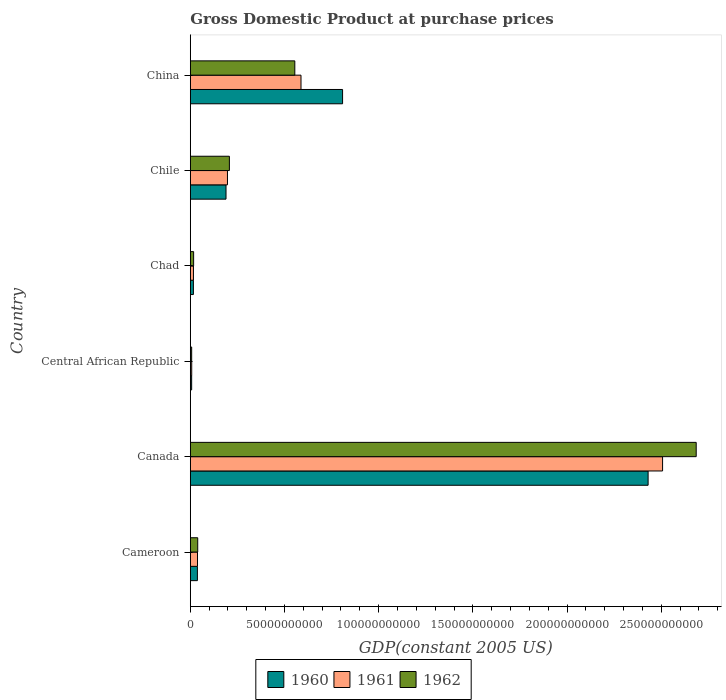How many different coloured bars are there?
Ensure brevity in your answer.  3. How many groups of bars are there?
Offer a terse response. 6. Are the number of bars per tick equal to the number of legend labels?
Keep it short and to the point. Yes. Are the number of bars on each tick of the Y-axis equal?
Offer a terse response. Yes. How many bars are there on the 6th tick from the bottom?
Offer a very short reply. 3. What is the GDP at purchase prices in 1960 in Canada?
Give a very brief answer. 2.43e+11. Across all countries, what is the maximum GDP at purchase prices in 1962?
Your response must be concise. 2.69e+11. Across all countries, what is the minimum GDP at purchase prices in 1961?
Give a very brief answer. 7.57e+08. In which country was the GDP at purchase prices in 1962 maximum?
Give a very brief answer. Canada. In which country was the GDP at purchase prices in 1961 minimum?
Provide a succinct answer. Central African Republic. What is the total GDP at purchase prices in 1962 in the graph?
Offer a very short reply. 3.51e+11. What is the difference between the GDP at purchase prices in 1960 in Cameroon and that in Canada?
Your answer should be very brief. -2.39e+11. What is the difference between the GDP at purchase prices in 1961 in Central African Republic and the GDP at purchase prices in 1960 in China?
Make the answer very short. -8.01e+1. What is the average GDP at purchase prices in 1960 per country?
Make the answer very short. 5.82e+1. What is the difference between the GDP at purchase prices in 1961 and GDP at purchase prices in 1962 in Chad?
Your answer should be compact. -8.98e+07. What is the ratio of the GDP at purchase prices in 1962 in Canada to that in Central African Republic?
Ensure brevity in your answer.  368.49. Is the GDP at purchase prices in 1962 in Cameroon less than that in Chile?
Offer a terse response. Yes. Is the difference between the GDP at purchase prices in 1961 in Canada and Central African Republic greater than the difference between the GDP at purchase prices in 1962 in Canada and Central African Republic?
Give a very brief answer. No. What is the difference between the highest and the second highest GDP at purchase prices in 1962?
Give a very brief answer. 2.13e+11. What is the difference between the highest and the lowest GDP at purchase prices in 1962?
Your answer should be very brief. 2.68e+11. In how many countries, is the GDP at purchase prices in 1961 greater than the average GDP at purchase prices in 1961 taken over all countries?
Your response must be concise. 2. Is the sum of the GDP at purchase prices in 1960 in Cameroon and Chad greater than the maximum GDP at purchase prices in 1961 across all countries?
Make the answer very short. No. What does the 2nd bar from the bottom in Chile represents?
Offer a terse response. 1961. How many countries are there in the graph?
Your response must be concise. 6. What is the difference between two consecutive major ticks on the X-axis?
Your response must be concise. 5.00e+1. Are the values on the major ticks of X-axis written in scientific E-notation?
Offer a very short reply. No. Does the graph contain any zero values?
Keep it short and to the point. No. Where does the legend appear in the graph?
Offer a terse response. Bottom center. What is the title of the graph?
Offer a very short reply. Gross Domestic Product at purchase prices. Does "1972" appear as one of the legend labels in the graph?
Your answer should be compact. No. What is the label or title of the X-axis?
Keep it short and to the point. GDP(constant 2005 US). What is the label or title of the Y-axis?
Keep it short and to the point. Country. What is the GDP(constant 2005 US) in 1960 in Cameroon?
Ensure brevity in your answer.  3.78e+09. What is the GDP(constant 2005 US) of 1961 in Cameroon?
Ensure brevity in your answer.  3.82e+09. What is the GDP(constant 2005 US) in 1962 in Cameroon?
Your response must be concise. 3.94e+09. What is the GDP(constant 2005 US) of 1960 in Canada?
Keep it short and to the point. 2.43e+11. What is the GDP(constant 2005 US) of 1961 in Canada?
Your response must be concise. 2.51e+11. What is the GDP(constant 2005 US) in 1962 in Canada?
Offer a very short reply. 2.69e+11. What is the GDP(constant 2005 US) in 1960 in Central African Republic?
Make the answer very short. 7.21e+08. What is the GDP(constant 2005 US) of 1961 in Central African Republic?
Give a very brief answer. 7.57e+08. What is the GDP(constant 2005 US) of 1962 in Central African Republic?
Your response must be concise. 7.29e+08. What is the GDP(constant 2005 US) in 1960 in Chad?
Ensure brevity in your answer.  1.65e+09. What is the GDP(constant 2005 US) in 1961 in Chad?
Your answer should be very brief. 1.68e+09. What is the GDP(constant 2005 US) of 1962 in Chad?
Keep it short and to the point. 1.77e+09. What is the GDP(constant 2005 US) in 1960 in Chile?
Ensure brevity in your answer.  1.90e+1. What is the GDP(constant 2005 US) of 1961 in Chile?
Provide a succinct answer. 1.97e+1. What is the GDP(constant 2005 US) of 1962 in Chile?
Offer a terse response. 2.08e+1. What is the GDP(constant 2005 US) of 1960 in China?
Give a very brief answer. 8.08e+1. What is the GDP(constant 2005 US) of 1961 in China?
Make the answer very short. 5.88e+1. What is the GDP(constant 2005 US) in 1962 in China?
Ensure brevity in your answer.  5.55e+1. Across all countries, what is the maximum GDP(constant 2005 US) in 1960?
Your response must be concise. 2.43e+11. Across all countries, what is the maximum GDP(constant 2005 US) of 1961?
Provide a short and direct response. 2.51e+11. Across all countries, what is the maximum GDP(constant 2005 US) of 1962?
Ensure brevity in your answer.  2.69e+11. Across all countries, what is the minimum GDP(constant 2005 US) in 1960?
Provide a short and direct response. 7.21e+08. Across all countries, what is the minimum GDP(constant 2005 US) of 1961?
Offer a very short reply. 7.57e+08. Across all countries, what is the minimum GDP(constant 2005 US) in 1962?
Offer a terse response. 7.29e+08. What is the total GDP(constant 2005 US) of 1960 in the graph?
Your answer should be very brief. 3.49e+11. What is the total GDP(constant 2005 US) of 1961 in the graph?
Provide a short and direct response. 3.35e+11. What is the total GDP(constant 2005 US) of 1962 in the graph?
Your response must be concise. 3.51e+11. What is the difference between the GDP(constant 2005 US) in 1960 in Cameroon and that in Canada?
Keep it short and to the point. -2.39e+11. What is the difference between the GDP(constant 2005 US) of 1961 in Cameroon and that in Canada?
Your answer should be compact. -2.47e+11. What is the difference between the GDP(constant 2005 US) in 1962 in Cameroon and that in Canada?
Offer a terse response. -2.65e+11. What is the difference between the GDP(constant 2005 US) in 1960 in Cameroon and that in Central African Republic?
Your answer should be compact. 3.06e+09. What is the difference between the GDP(constant 2005 US) in 1961 in Cameroon and that in Central African Republic?
Keep it short and to the point. 3.07e+09. What is the difference between the GDP(constant 2005 US) in 1962 in Cameroon and that in Central African Republic?
Your answer should be very brief. 3.21e+09. What is the difference between the GDP(constant 2005 US) in 1960 in Cameroon and that in Chad?
Make the answer very short. 2.13e+09. What is the difference between the GDP(constant 2005 US) in 1961 in Cameroon and that in Chad?
Your answer should be very brief. 2.15e+09. What is the difference between the GDP(constant 2005 US) in 1962 in Cameroon and that in Chad?
Your answer should be very brief. 2.17e+09. What is the difference between the GDP(constant 2005 US) of 1960 in Cameroon and that in Chile?
Ensure brevity in your answer.  -1.52e+1. What is the difference between the GDP(constant 2005 US) in 1961 in Cameroon and that in Chile?
Your answer should be compact. -1.59e+1. What is the difference between the GDP(constant 2005 US) of 1962 in Cameroon and that in Chile?
Offer a very short reply. -1.68e+1. What is the difference between the GDP(constant 2005 US) of 1960 in Cameroon and that in China?
Your answer should be compact. -7.71e+1. What is the difference between the GDP(constant 2005 US) of 1961 in Cameroon and that in China?
Offer a terse response. -5.49e+1. What is the difference between the GDP(constant 2005 US) in 1962 in Cameroon and that in China?
Provide a succinct answer. -5.15e+1. What is the difference between the GDP(constant 2005 US) of 1960 in Canada and that in Central African Republic?
Your answer should be very brief. 2.42e+11. What is the difference between the GDP(constant 2005 US) in 1961 in Canada and that in Central African Republic?
Give a very brief answer. 2.50e+11. What is the difference between the GDP(constant 2005 US) in 1962 in Canada and that in Central African Republic?
Your answer should be very brief. 2.68e+11. What is the difference between the GDP(constant 2005 US) of 1960 in Canada and that in Chad?
Offer a very short reply. 2.41e+11. What is the difference between the GDP(constant 2005 US) of 1961 in Canada and that in Chad?
Your answer should be very brief. 2.49e+11. What is the difference between the GDP(constant 2005 US) in 1962 in Canada and that in Chad?
Provide a succinct answer. 2.67e+11. What is the difference between the GDP(constant 2005 US) in 1960 in Canada and that in Chile?
Keep it short and to the point. 2.24e+11. What is the difference between the GDP(constant 2005 US) of 1961 in Canada and that in Chile?
Make the answer very short. 2.31e+11. What is the difference between the GDP(constant 2005 US) in 1962 in Canada and that in Chile?
Provide a short and direct response. 2.48e+11. What is the difference between the GDP(constant 2005 US) in 1960 in Canada and that in China?
Offer a terse response. 1.62e+11. What is the difference between the GDP(constant 2005 US) in 1961 in Canada and that in China?
Keep it short and to the point. 1.92e+11. What is the difference between the GDP(constant 2005 US) in 1962 in Canada and that in China?
Provide a succinct answer. 2.13e+11. What is the difference between the GDP(constant 2005 US) in 1960 in Central African Republic and that in Chad?
Offer a very short reply. -9.31e+08. What is the difference between the GDP(constant 2005 US) of 1961 in Central African Republic and that in Chad?
Give a very brief answer. -9.18e+08. What is the difference between the GDP(constant 2005 US) in 1962 in Central African Republic and that in Chad?
Make the answer very short. -1.04e+09. What is the difference between the GDP(constant 2005 US) of 1960 in Central African Republic and that in Chile?
Provide a succinct answer. -1.82e+1. What is the difference between the GDP(constant 2005 US) in 1961 in Central African Republic and that in Chile?
Make the answer very short. -1.90e+1. What is the difference between the GDP(constant 2005 US) in 1962 in Central African Republic and that in Chile?
Provide a succinct answer. -2.00e+1. What is the difference between the GDP(constant 2005 US) in 1960 in Central African Republic and that in China?
Offer a terse response. -8.01e+1. What is the difference between the GDP(constant 2005 US) of 1961 in Central African Republic and that in China?
Your answer should be very brief. -5.80e+1. What is the difference between the GDP(constant 2005 US) in 1962 in Central African Republic and that in China?
Your answer should be very brief. -5.48e+1. What is the difference between the GDP(constant 2005 US) of 1960 in Chad and that in Chile?
Provide a short and direct response. -1.73e+1. What is the difference between the GDP(constant 2005 US) in 1961 in Chad and that in Chile?
Ensure brevity in your answer.  -1.81e+1. What is the difference between the GDP(constant 2005 US) in 1962 in Chad and that in Chile?
Give a very brief answer. -1.90e+1. What is the difference between the GDP(constant 2005 US) in 1960 in Chad and that in China?
Offer a very short reply. -7.92e+1. What is the difference between the GDP(constant 2005 US) of 1961 in Chad and that in China?
Your answer should be compact. -5.71e+1. What is the difference between the GDP(constant 2005 US) in 1962 in Chad and that in China?
Provide a short and direct response. -5.37e+1. What is the difference between the GDP(constant 2005 US) in 1960 in Chile and that in China?
Make the answer very short. -6.19e+1. What is the difference between the GDP(constant 2005 US) in 1961 in Chile and that in China?
Ensure brevity in your answer.  -3.90e+1. What is the difference between the GDP(constant 2005 US) in 1962 in Chile and that in China?
Your answer should be very brief. -3.47e+1. What is the difference between the GDP(constant 2005 US) in 1960 in Cameroon and the GDP(constant 2005 US) in 1961 in Canada?
Make the answer very short. -2.47e+11. What is the difference between the GDP(constant 2005 US) in 1960 in Cameroon and the GDP(constant 2005 US) in 1962 in Canada?
Provide a short and direct response. -2.65e+11. What is the difference between the GDP(constant 2005 US) of 1961 in Cameroon and the GDP(constant 2005 US) of 1962 in Canada?
Provide a short and direct response. -2.65e+11. What is the difference between the GDP(constant 2005 US) of 1960 in Cameroon and the GDP(constant 2005 US) of 1961 in Central African Republic?
Provide a succinct answer. 3.02e+09. What is the difference between the GDP(constant 2005 US) of 1960 in Cameroon and the GDP(constant 2005 US) of 1962 in Central African Republic?
Give a very brief answer. 3.05e+09. What is the difference between the GDP(constant 2005 US) in 1961 in Cameroon and the GDP(constant 2005 US) in 1962 in Central African Republic?
Keep it short and to the point. 3.09e+09. What is the difference between the GDP(constant 2005 US) in 1960 in Cameroon and the GDP(constant 2005 US) in 1961 in Chad?
Offer a very short reply. 2.10e+09. What is the difference between the GDP(constant 2005 US) of 1960 in Cameroon and the GDP(constant 2005 US) of 1962 in Chad?
Give a very brief answer. 2.01e+09. What is the difference between the GDP(constant 2005 US) in 1961 in Cameroon and the GDP(constant 2005 US) in 1962 in Chad?
Your response must be concise. 2.06e+09. What is the difference between the GDP(constant 2005 US) of 1960 in Cameroon and the GDP(constant 2005 US) of 1961 in Chile?
Keep it short and to the point. -1.60e+1. What is the difference between the GDP(constant 2005 US) in 1960 in Cameroon and the GDP(constant 2005 US) in 1962 in Chile?
Provide a short and direct response. -1.70e+1. What is the difference between the GDP(constant 2005 US) in 1961 in Cameroon and the GDP(constant 2005 US) in 1962 in Chile?
Offer a terse response. -1.69e+1. What is the difference between the GDP(constant 2005 US) of 1960 in Cameroon and the GDP(constant 2005 US) of 1961 in China?
Your answer should be compact. -5.50e+1. What is the difference between the GDP(constant 2005 US) of 1960 in Cameroon and the GDP(constant 2005 US) of 1962 in China?
Provide a short and direct response. -5.17e+1. What is the difference between the GDP(constant 2005 US) of 1961 in Cameroon and the GDP(constant 2005 US) of 1962 in China?
Ensure brevity in your answer.  -5.17e+1. What is the difference between the GDP(constant 2005 US) in 1960 in Canada and the GDP(constant 2005 US) in 1961 in Central African Republic?
Your answer should be compact. 2.42e+11. What is the difference between the GDP(constant 2005 US) of 1960 in Canada and the GDP(constant 2005 US) of 1962 in Central African Republic?
Your answer should be compact. 2.42e+11. What is the difference between the GDP(constant 2005 US) of 1961 in Canada and the GDP(constant 2005 US) of 1962 in Central African Republic?
Provide a short and direct response. 2.50e+11. What is the difference between the GDP(constant 2005 US) in 1960 in Canada and the GDP(constant 2005 US) in 1961 in Chad?
Offer a terse response. 2.41e+11. What is the difference between the GDP(constant 2005 US) in 1960 in Canada and the GDP(constant 2005 US) in 1962 in Chad?
Provide a succinct answer. 2.41e+11. What is the difference between the GDP(constant 2005 US) of 1961 in Canada and the GDP(constant 2005 US) of 1962 in Chad?
Provide a succinct answer. 2.49e+11. What is the difference between the GDP(constant 2005 US) of 1960 in Canada and the GDP(constant 2005 US) of 1961 in Chile?
Provide a succinct answer. 2.23e+11. What is the difference between the GDP(constant 2005 US) of 1960 in Canada and the GDP(constant 2005 US) of 1962 in Chile?
Ensure brevity in your answer.  2.22e+11. What is the difference between the GDP(constant 2005 US) of 1961 in Canada and the GDP(constant 2005 US) of 1962 in Chile?
Keep it short and to the point. 2.30e+11. What is the difference between the GDP(constant 2005 US) in 1960 in Canada and the GDP(constant 2005 US) in 1961 in China?
Your answer should be compact. 1.84e+11. What is the difference between the GDP(constant 2005 US) in 1960 in Canada and the GDP(constant 2005 US) in 1962 in China?
Give a very brief answer. 1.88e+11. What is the difference between the GDP(constant 2005 US) in 1961 in Canada and the GDP(constant 2005 US) in 1962 in China?
Give a very brief answer. 1.95e+11. What is the difference between the GDP(constant 2005 US) of 1960 in Central African Republic and the GDP(constant 2005 US) of 1961 in Chad?
Ensure brevity in your answer.  -9.54e+08. What is the difference between the GDP(constant 2005 US) of 1960 in Central African Republic and the GDP(constant 2005 US) of 1962 in Chad?
Your answer should be compact. -1.04e+09. What is the difference between the GDP(constant 2005 US) in 1961 in Central African Republic and the GDP(constant 2005 US) in 1962 in Chad?
Ensure brevity in your answer.  -1.01e+09. What is the difference between the GDP(constant 2005 US) in 1960 in Central African Republic and the GDP(constant 2005 US) in 1961 in Chile?
Your response must be concise. -1.90e+1. What is the difference between the GDP(constant 2005 US) in 1960 in Central African Republic and the GDP(constant 2005 US) in 1962 in Chile?
Make the answer very short. -2.00e+1. What is the difference between the GDP(constant 2005 US) of 1961 in Central African Republic and the GDP(constant 2005 US) of 1962 in Chile?
Your answer should be very brief. -2.00e+1. What is the difference between the GDP(constant 2005 US) in 1960 in Central African Republic and the GDP(constant 2005 US) in 1961 in China?
Ensure brevity in your answer.  -5.81e+1. What is the difference between the GDP(constant 2005 US) in 1960 in Central African Republic and the GDP(constant 2005 US) in 1962 in China?
Provide a succinct answer. -5.48e+1. What is the difference between the GDP(constant 2005 US) of 1961 in Central African Republic and the GDP(constant 2005 US) of 1962 in China?
Provide a short and direct response. -5.47e+1. What is the difference between the GDP(constant 2005 US) of 1960 in Chad and the GDP(constant 2005 US) of 1961 in Chile?
Your answer should be compact. -1.81e+1. What is the difference between the GDP(constant 2005 US) of 1960 in Chad and the GDP(constant 2005 US) of 1962 in Chile?
Provide a short and direct response. -1.91e+1. What is the difference between the GDP(constant 2005 US) of 1961 in Chad and the GDP(constant 2005 US) of 1962 in Chile?
Your answer should be very brief. -1.91e+1. What is the difference between the GDP(constant 2005 US) of 1960 in Chad and the GDP(constant 2005 US) of 1961 in China?
Ensure brevity in your answer.  -5.71e+1. What is the difference between the GDP(constant 2005 US) of 1960 in Chad and the GDP(constant 2005 US) of 1962 in China?
Keep it short and to the point. -5.38e+1. What is the difference between the GDP(constant 2005 US) in 1961 in Chad and the GDP(constant 2005 US) in 1962 in China?
Your answer should be compact. -5.38e+1. What is the difference between the GDP(constant 2005 US) in 1960 in Chile and the GDP(constant 2005 US) in 1961 in China?
Offer a very short reply. -3.98e+1. What is the difference between the GDP(constant 2005 US) of 1960 in Chile and the GDP(constant 2005 US) of 1962 in China?
Your answer should be very brief. -3.65e+1. What is the difference between the GDP(constant 2005 US) in 1961 in Chile and the GDP(constant 2005 US) in 1962 in China?
Your answer should be compact. -3.58e+1. What is the average GDP(constant 2005 US) of 1960 per country?
Your answer should be very brief. 5.82e+1. What is the average GDP(constant 2005 US) in 1961 per country?
Your answer should be very brief. 5.59e+1. What is the average GDP(constant 2005 US) of 1962 per country?
Offer a very short reply. 5.85e+1. What is the difference between the GDP(constant 2005 US) of 1960 and GDP(constant 2005 US) of 1961 in Cameroon?
Provide a succinct answer. -4.47e+07. What is the difference between the GDP(constant 2005 US) in 1960 and GDP(constant 2005 US) in 1962 in Cameroon?
Your answer should be very brief. -1.61e+08. What is the difference between the GDP(constant 2005 US) of 1961 and GDP(constant 2005 US) of 1962 in Cameroon?
Offer a terse response. -1.16e+08. What is the difference between the GDP(constant 2005 US) in 1960 and GDP(constant 2005 US) in 1961 in Canada?
Provide a succinct answer. -7.69e+09. What is the difference between the GDP(constant 2005 US) of 1960 and GDP(constant 2005 US) of 1962 in Canada?
Provide a short and direct response. -2.55e+1. What is the difference between the GDP(constant 2005 US) of 1961 and GDP(constant 2005 US) of 1962 in Canada?
Your response must be concise. -1.78e+1. What is the difference between the GDP(constant 2005 US) in 1960 and GDP(constant 2005 US) in 1961 in Central African Republic?
Make the answer very short. -3.57e+07. What is the difference between the GDP(constant 2005 US) in 1960 and GDP(constant 2005 US) in 1962 in Central African Republic?
Keep it short and to the point. -7.62e+06. What is the difference between the GDP(constant 2005 US) in 1961 and GDP(constant 2005 US) in 1962 in Central African Republic?
Keep it short and to the point. 2.81e+07. What is the difference between the GDP(constant 2005 US) in 1960 and GDP(constant 2005 US) in 1961 in Chad?
Offer a very short reply. -2.31e+07. What is the difference between the GDP(constant 2005 US) in 1960 and GDP(constant 2005 US) in 1962 in Chad?
Your answer should be very brief. -1.13e+08. What is the difference between the GDP(constant 2005 US) of 1961 and GDP(constant 2005 US) of 1962 in Chad?
Your answer should be compact. -8.98e+07. What is the difference between the GDP(constant 2005 US) in 1960 and GDP(constant 2005 US) in 1961 in Chile?
Ensure brevity in your answer.  -7.68e+08. What is the difference between the GDP(constant 2005 US) in 1960 and GDP(constant 2005 US) in 1962 in Chile?
Keep it short and to the point. -1.79e+09. What is the difference between the GDP(constant 2005 US) of 1961 and GDP(constant 2005 US) of 1962 in Chile?
Your answer should be very brief. -1.02e+09. What is the difference between the GDP(constant 2005 US) in 1960 and GDP(constant 2005 US) in 1961 in China?
Your response must be concise. 2.21e+1. What is the difference between the GDP(constant 2005 US) in 1960 and GDP(constant 2005 US) in 1962 in China?
Offer a terse response. 2.54e+1. What is the difference between the GDP(constant 2005 US) of 1961 and GDP(constant 2005 US) of 1962 in China?
Your answer should be very brief. 3.29e+09. What is the ratio of the GDP(constant 2005 US) in 1960 in Cameroon to that in Canada?
Your answer should be compact. 0.02. What is the ratio of the GDP(constant 2005 US) in 1961 in Cameroon to that in Canada?
Your answer should be very brief. 0.02. What is the ratio of the GDP(constant 2005 US) of 1962 in Cameroon to that in Canada?
Make the answer very short. 0.01. What is the ratio of the GDP(constant 2005 US) of 1960 in Cameroon to that in Central African Republic?
Ensure brevity in your answer.  5.24. What is the ratio of the GDP(constant 2005 US) in 1961 in Cameroon to that in Central African Republic?
Offer a terse response. 5.05. What is the ratio of the GDP(constant 2005 US) in 1962 in Cameroon to that in Central African Republic?
Provide a short and direct response. 5.41. What is the ratio of the GDP(constant 2005 US) in 1960 in Cameroon to that in Chad?
Your answer should be compact. 2.29. What is the ratio of the GDP(constant 2005 US) in 1961 in Cameroon to that in Chad?
Offer a very short reply. 2.28. What is the ratio of the GDP(constant 2005 US) in 1962 in Cameroon to that in Chad?
Provide a short and direct response. 2.23. What is the ratio of the GDP(constant 2005 US) in 1960 in Cameroon to that in Chile?
Give a very brief answer. 0.2. What is the ratio of the GDP(constant 2005 US) in 1961 in Cameroon to that in Chile?
Provide a short and direct response. 0.19. What is the ratio of the GDP(constant 2005 US) of 1962 in Cameroon to that in Chile?
Ensure brevity in your answer.  0.19. What is the ratio of the GDP(constant 2005 US) of 1960 in Cameroon to that in China?
Your answer should be compact. 0.05. What is the ratio of the GDP(constant 2005 US) of 1961 in Cameroon to that in China?
Give a very brief answer. 0.07. What is the ratio of the GDP(constant 2005 US) of 1962 in Cameroon to that in China?
Keep it short and to the point. 0.07. What is the ratio of the GDP(constant 2005 US) in 1960 in Canada to that in Central African Republic?
Provide a short and direct response. 336.98. What is the ratio of the GDP(constant 2005 US) of 1961 in Canada to that in Central African Republic?
Keep it short and to the point. 331.23. What is the ratio of the GDP(constant 2005 US) of 1962 in Canada to that in Central African Republic?
Make the answer very short. 368.49. What is the ratio of the GDP(constant 2005 US) of 1960 in Canada to that in Chad?
Provide a short and direct response. 147.1. What is the ratio of the GDP(constant 2005 US) of 1961 in Canada to that in Chad?
Ensure brevity in your answer.  149.67. What is the ratio of the GDP(constant 2005 US) in 1962 in Canada to that in Chad?
Keep it short and to the point. 152.16. What is the ratio of the GDP(constant 2005 US) of 1960 in Canada to that in Chile?
Provide a succinct answer. 12.82. What is the ratio of the GDP(constant 2005 US) of 1961 in Canada to that in Chile?
Your response must be concise. 12.71. What is the ratio of the GDP(constant 2005 US) of 1962 in Canada to that in Chile?
Your answer should be compact. 12.94. What is the ratio of the GDP(constant 2005 US) of 1960 in Canada to that in China?
Make the answer very short. 3.01. What is the ratio of the GDP(constant 2005 US) in 1961 in Canada to that in China?
Provide a short and direct response. 4.27. What is the ratio of the GDP(constant 2005 US) in 1962 in Canada to that in China?
Provide a short and direct response. 4.84. What is the ratio of the GDP(constant 2005 US) of 1960 in Central African Republic to that in Chad?
Keep it short and to the point. 0.44. What is the ratio of the GDP(constant 2005 US) of 1961 in Central African Republic to that in Chad?
Offer a very short reply. 0.45. What is the ratio of the GDP(constant 2005 US) of 1962 in Central African Republic to that in Chad?
Offer a very short reply. 0.41. What is the ratio of the GDP(constant 2005 US) in 1960 in Central African Republic to that in Chile?
Offer a terse response. 0.04. What is the ratio of the GDP(constant 2005 US) in 1961 in Central African Republic to that in Chile?
Provide a short and direct response. 0.04. What is the ratio of the GDP(constant 2005 US) in 1962 in Central African Republic to that in Chile?
Make the answer very short. 0.04. What is the ratio of the GDP(constant 2005 US) in 1960 in Central African Republic to that in China?
Provide a short and direct response. 0.01. What is the ratio of the GDP(constant 2005 US) of 1961 in Central African Republic to that in China?
Provide a succinct answer. 0.01. What is the ratio of the GDP(constant 2005 US) in 1962 in Central African Republic to that in China?
Your answer should be compact. 0.01. What is the ratio of the GDP(constant 2005 US) of 1960 in Chad to that in Chile?
Your answer should be very brief. 0.09. What is the ratio of the GDP(constant 2005 US) of 1961 in Chad to that in Chile?
Make the answer very short. 0.08. What is the ratio of the GDP(constant 2005 US) in 1962 in Chad to that in Chile?
Provide a succinct answer. 0.09. What is the ratio of the GDP(constant 2005 US) of 1960 in Chad to that in China?
Provide a succinct answer. 0.02. What is the ratio of the GDP(constant 2005 US) in 1961 in Chad to that in China?
Provide a succinct answer. 0.03. What is the ratio of the GDP(constant 2005 US) in 1962 in Chad to that in China?
Make the answer very short. 0.03. What is the ratio of the GDP(constant 2005 US) in 1960 in Chile to that in China?
Keep it short and to the point. 0.23. What is the ratio of the GDP(constant 2005 US) of 1961 in Chile to that in China?
Make the answer very short. 0.34. What is the ratio of the GDP(constant 2005 US) in 1962 in Chile to that in China?
Give a very brief answer. 0.37. What is the difference between the highest and the second highest GDP(constant 2005 US) of 1960?
Ensure brevity in your answer.  1.62e+11. What is the difference between the highest and the second highest GDP(constant 2005 US) of 1961?
Your answer should be compact. 1.92e+11. What is the difference between the highest and the second highest GDP(constant 2005 US) in 1962?
Your response must be concise. 2.13e+11. What is the difference between the highest and the lowest GDP(constant 2005 US) of 1960?
Your answer should be compact. 2.42e+11. What is the difference between the highest and the lowest GDP(constant 2005 US) in 1961?
Ensure brevity in your answer.  2.50e+11. What is the difference between the highest and the lowest GDP(constant 2005 US) of 1962?
Provide a short and direct response. 2.68e+11. 